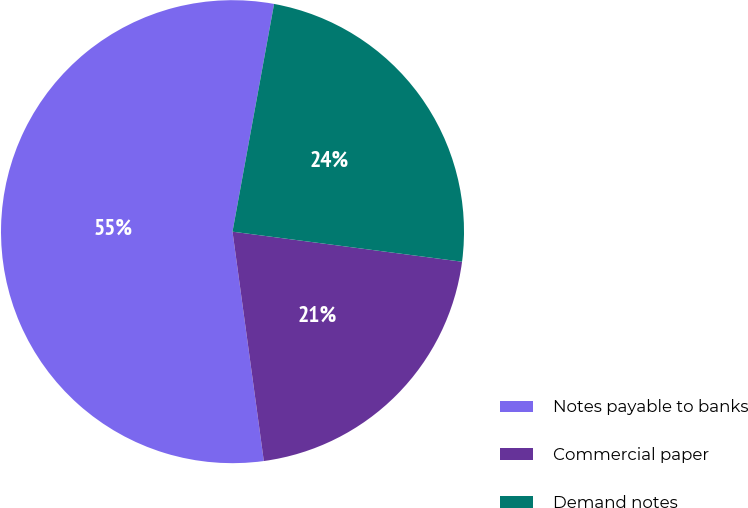<chart> <loc_0><loc_0><loc_500><loc_500><pie_chart><fcel>Notes payable to banks<fcel>Commercial paper<fcel>Demand notes<nl><fcel>55.04%<fcel>20.77%<fcel>24.2%<nl></chart> 